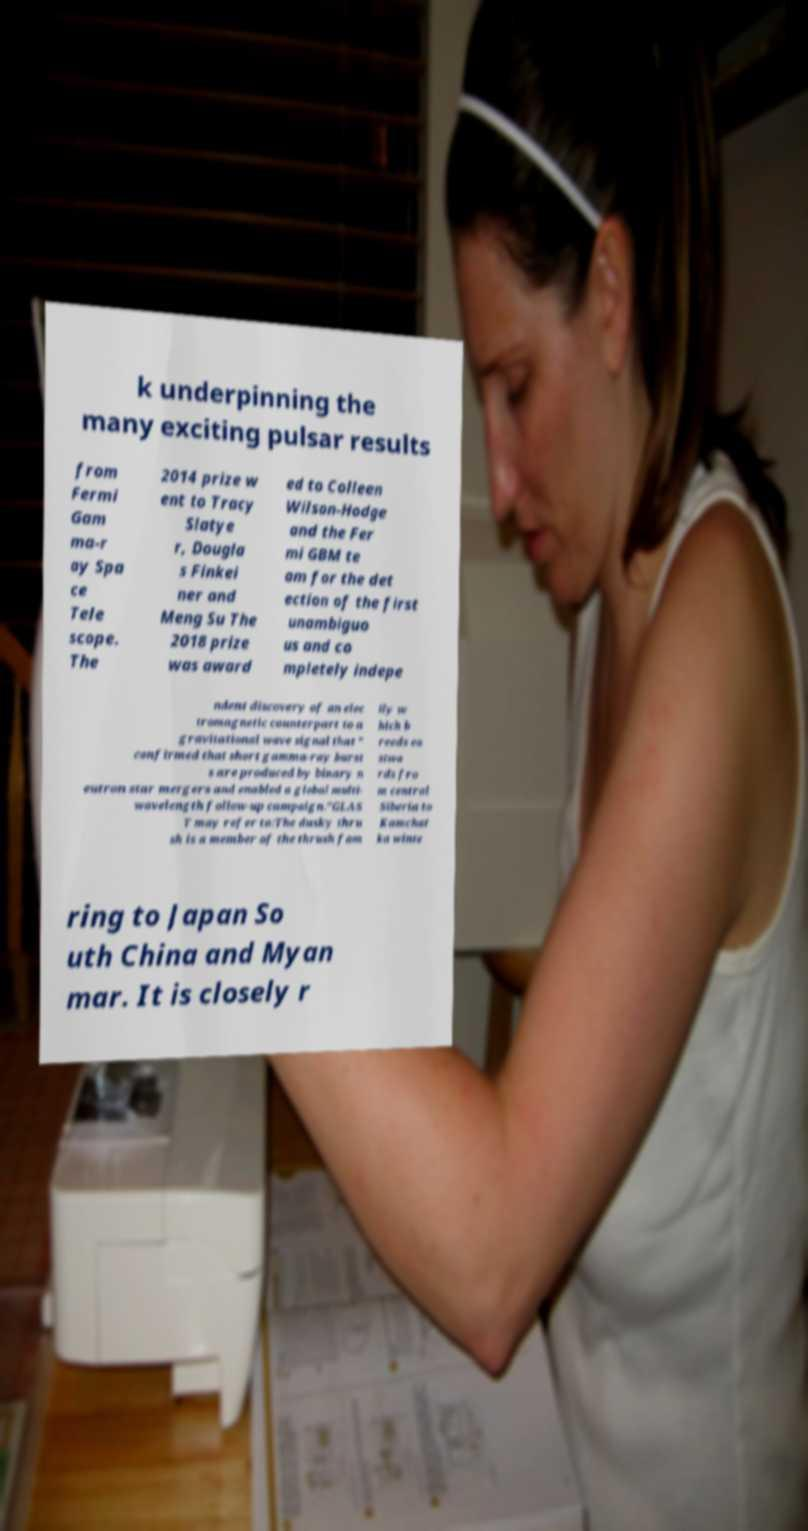Please identify and transcribe the text found in this image. k underpinning the many exciting pulsar results from Fermi Gam ma-r ay Spa ce Tele scope. The 2014 prize w ent to Tracy Slatye r, Dougla s Finkei ner and Meng Su The 2018 prize was award ed to Colleen Wilson-Hodge and the Fer mi GBM te am for the det ection of the first unambiguo us and co mpletely indepe ndent discovery of an elec tromagnetic counterpart to a gravitational wave signal that " confirmed that short gamma-ray burst s are produced by binary n eutron star mergers and enabled a global multi- wavelength follow-up campaign."GLAS T may refer to:The dusky thru sh is a member of the thrush fam ily w hich b reeds ea stwa rds fro m central Siberia to Kamchat ka winte ring to Japan So uth China and Myan mar. It is closely r 